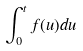<formula> <loc_0><loc_0><loc_500><loc_500>\int _ { 0 } ^ { t } f ( u ) d u</formula> 